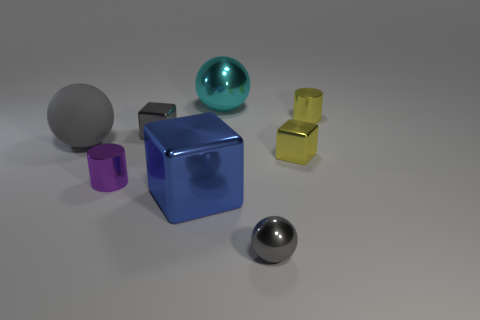Add 1 small yellow cubes. How many objects exist? 9 Subtract 0 green balls. How many objects are left? 8 Subtract all cylinders. How many objects are left? 6 Subtract 1 spheres. How many spheres are left? 2 Subtract all purple spheres. Subtract all blue cylinders. How many spheres are left? 3 Subtract all gray spheres. How many purple cylinders are left? 1 Subtract all gray shiny blocks. Subtract all big cyan cylinders. How many objects are left? 7 Add 7 large gray balls. How many large gray balls are left? 8 Add 3 large blue objects. How many large blue objects exist? 4 Subtract all cyan spheres. How many spheres are left? 2 